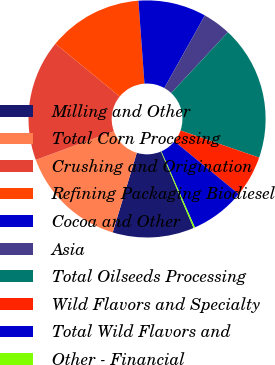Convert chart. <chart><loc_0><loc_0><loc_500><loc_500><pie_chart><fcel>Milling and Other<fcel>Total Corn Processing<fcel>Crushing and Origination<fcel>Refining Packaging Biodiesel<fcel>Cocoa and Other<fcel>Asia<fcel>Total Oilseeds Processing<fcel>Wild Flavors and Specialty<fcel>Total Wild Flavors and<fcel>Other - Financial<nl><fcel>11.09%<fcel>14.72%<fcel>16.54%<fcel>12.9%<fcel>9.27%<fcel>3.83%<fcel>18.35%<fcel>5.64%<fcel>7.46%<fcel>0.2%<nl></chart> 